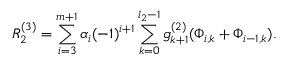Convert formula to latex. <formula><loc_0><loc_0><loc_500><loc_500>R _ { 2 } ^ { \left ( 3 \right ) } = \sum _ { i = 3 } ^ { m + 1 } \alpha _ { i } ( - 1 ) ^ { i + 1 } \sum _ { k = 0 } ^ { l _ { 2 } - 1 } g _ { k + 1 } ^ { \left ( 2 \right ) } ( \Phi _ { i , k } + \Phi _ { i - 1 , k } ) .</formula> 